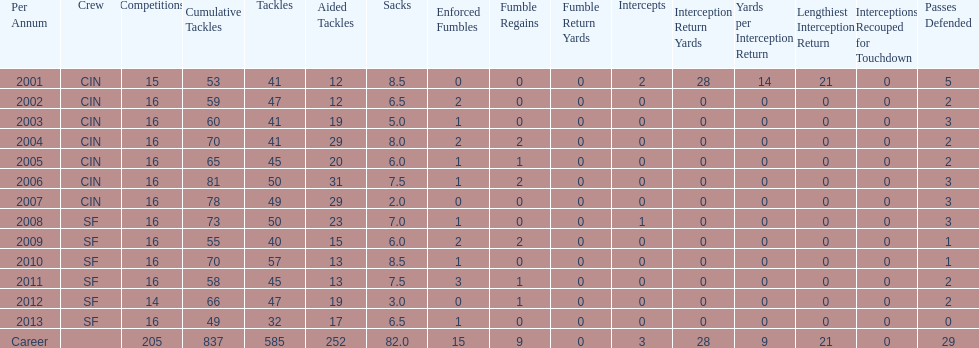Would you mind parsing the complete table? {'header': ['Per Annum', 'Crew', 'Competitions', 'Cumulative Tackles', 'Tackles', 'Aided Tackles', 'Sacks', 'Enforced Fumbles', 'Fumble Regains', 'Fumble Return Yards', 'Intercepts', 'Interception Return Yards', 'Yards per Interception Return', 'Lengthiest Interception Return', 'Interceptions Recouped for Touchdown', 'Passes Defended'], 'rows': [['2001', 'CIN', '15', '53', '41', '12', '8.5', '0', '0', '0', '2', '28', '14', '21', '0', '5'], ['2002', 'CIN', '16', '59', '47', '12', '6.5', '2', '0', '0', '0', '0', '0', '0', '0', '2'], ['2003', 'CIN', '16', '60', '41', '19', '5.0', '1', '0', '0', '0', '0', '0', '0', '0', '3'], ['2004', 'CIN', '16', '70', '41', '29', '8.0', '2', '2', '0', '0', '0', '0', '0', '0', '2'], ['2005', 'CIN', '16', '65', '45', '20', '6.0', '1', '1', '0', '0', '0', '0', '0', '0', '2'], ['2006', 'CIN', '16', '81', '50', '31', '7.5', '1', '2', '0', '0', '0', '0', '0', '0', '3'], ['2007', 'CIN', '16', '78', '49', '29', '2.0', '0', '0', '0', '0', '0', '0', '0', '0', '3'], ['2008', 'SF', '16', '73', '50', '23', '7.0', '1', '0', '0', '1', '0', '0', '0', '0', '3'], ['2009', 'SF', '16', '55', '40', '15', '6.0', '2', '2', '0', '0', '0', '0', '0', '0', '1'], ['2010', 'SF', '16', '70', '57', '13', '8.5', '1', '0', '0', '0', '0', '0', '0', '0', '1'], ['2011', 'SF', '16', '58', '45', '13', '7.5', '3', '1', '0', '0', '0', '0', '0', '0', '2'], ['2012', 'SF', '14', '66', '47', '19', '3.0', '0', '1', '0', '0', '0', '0', '0', '0', '2'], ['2013', 'SF', '16', '49', '32', '17', '6.5', '1', '0', '0', '0', '0', '0', '0', '0', '0'], ['Career', '', '205', '837', '585', '252', '82.0', '15', '9', '0', '3', '28', '9', '21', '0', '29']]} How many sacks did this player have in his first five seasons? 34. 